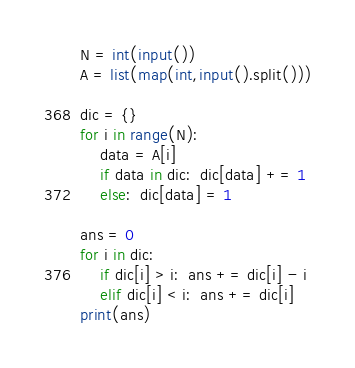Convert code to text. <code><loc_0><loc_0><loc_500><loc_500><_Python_>N = int(input())
A = list(map(int,input().split()))

dic = {}
for i in range(N):
    data = A[i]
    if data in dic:  dic[data] += 1
    else:  dic[data] = 1
        
ans = 0
for i in dic:
    if dic[i] > i:  ans += dic[i] - i
    elif dic[i] < i:  ans += dic[i]
print(ans)</code> 